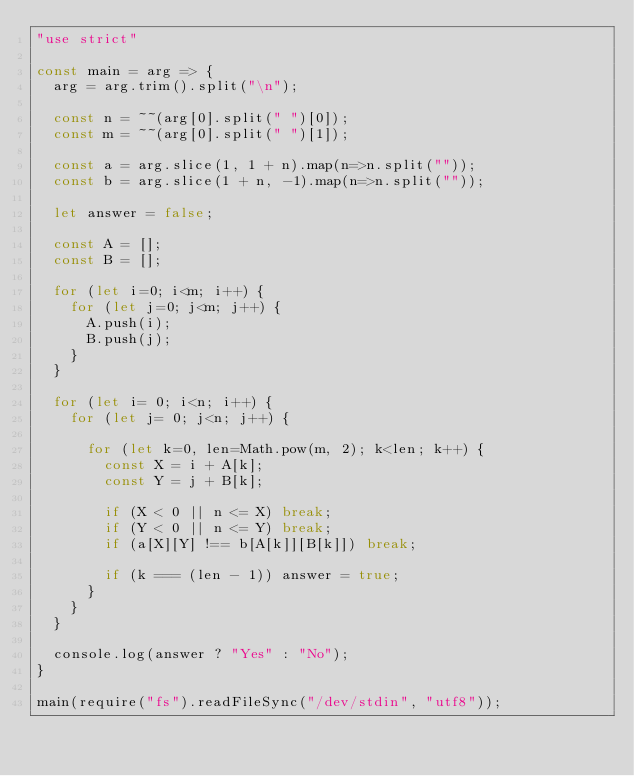Convert code to text. <code><loc_0><loc_0><loc_500><loc_500><_JavaScript_>"use strict"

const main = arg => {
  arg = arg.trim().split("\n");

  const n = ~~(arg[0].split(" ")[0]);
  const m = ~~(arg[0].split(" ")[1]);

  const a = arg.slice(1, 1 + n).map(n=>n.split(""));
  const b = arg.slice(1 + n, -1).map(n=>n.split(""));

  let answer = false;

  const A = [];
  const B = [];

  for (let i=0; i<m; i++) {
    for (let j=0; j<m; j++) {
      A.push(i);
      B.push(j);
    }
  }

  for (let i= 0; i<n; i++) {
    for (let j= 0; j<n; j++) {
      
      for (let k=0, len=Math.pow(m, 2); k<len; k++) {
        const X = i + A[k];
        const Y = j + B[k];

        if (X < 0 || n <= X) break;
        if (Y < 0 || n <= Y) break;
        if (a[X][Y] !== b[A[k]][B[k]]) break;

        if (k === (len - 1)) answer = true;
      }
    }
  }

  console.log(answer ? "Yes" : "No");
}

main(require("fs").readFileSync("/dev/stdin", "utf8"));
</code> 